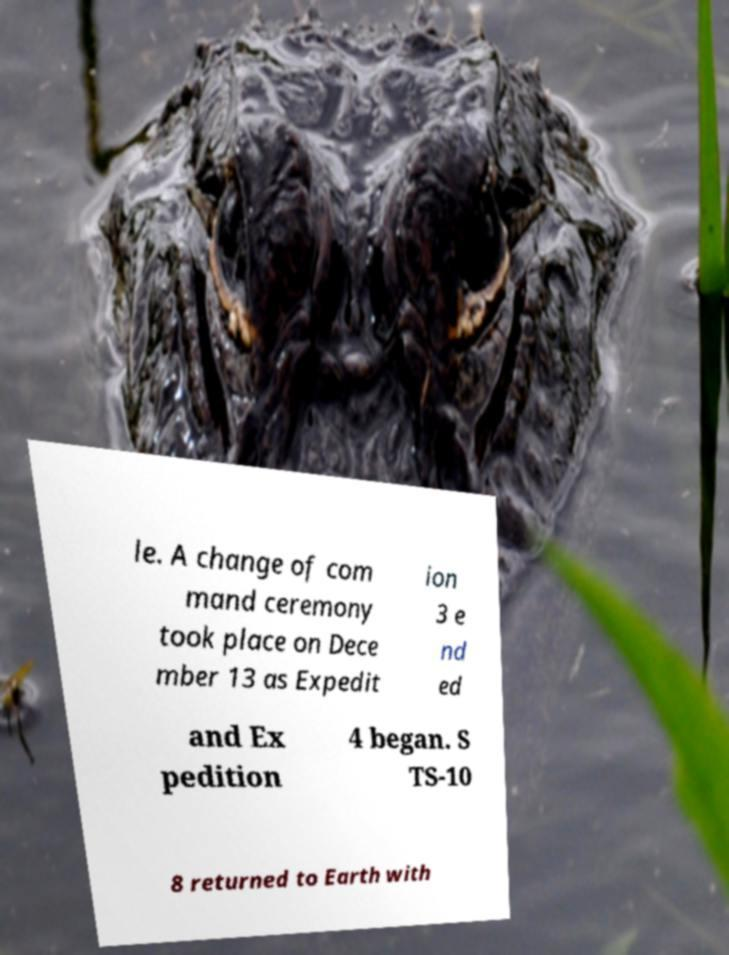What messages or text are displayed in this image? I need them in a readable, typed format. le. A change of com mand ceremony took place on Dece mber 13 as Expedit ion 3 e nd ed and Ex pedition 4 began. S TS-10 8 returned to Earth with 